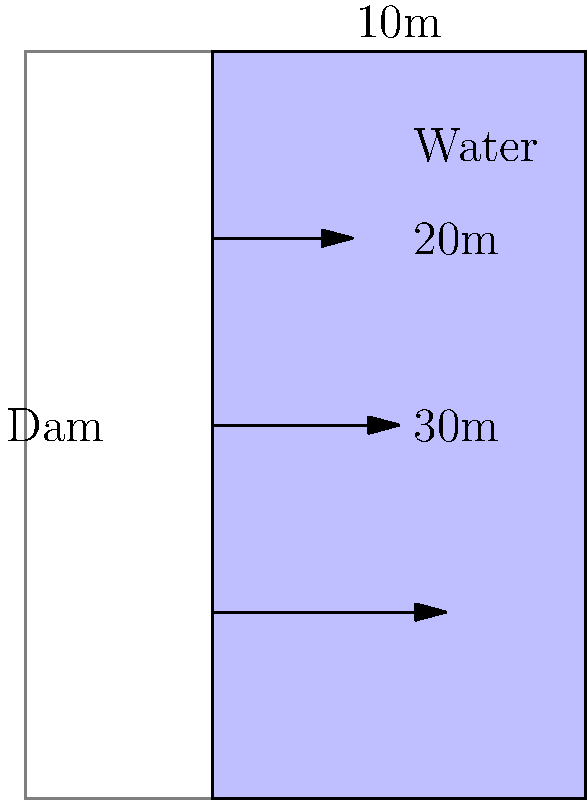Imagine you're designing a restaurant with a unique aquarium feature that mimics a dam reservoir. To ensure the safety and structural integrity of this feature, you need to calculate the water pressure at different depths. Given that the density of water is 1000 kg/m³ and gravitational acceleration is 9.8 m/s², what would be the water pressure at a depth of 20 meters in your restaurant's dam-inspired aquarium? Let's approach this step-by-step:

1) The formula for hydrostatic pressure is:

   $$P = \rho \cdot g \cdot h$$

   Where:
   $P$ = pressure (in Pascals, Pa)
   $\rho$ (rho) = density of the fluid (in kg/m³)
   $g$ = gravitational acceleration (in m/s²)
   $h$ = depth (in meters)

2) We're given:
   $\rho = 1000$ kg/m³
   $g = 9.8$ m/s²
   $h = 20$ m

3) Let's substitute these values into our equation:

   $$P = 1000 \cdot 9.8 \cdot 20$$

4) Now, let's calculate:

   $$P = 196,000 \text{ Pa}$$

5) It's often more convenient to express this in kilopascals (kPa):

   $$P = 196 \text{ kPa}$$

This pressure is equivalent to about 1.93 atmospheres, which is quite significant and demonstrates why proper engineering is crucial in dam and large aquarium design.
Answer: 196 kPa 